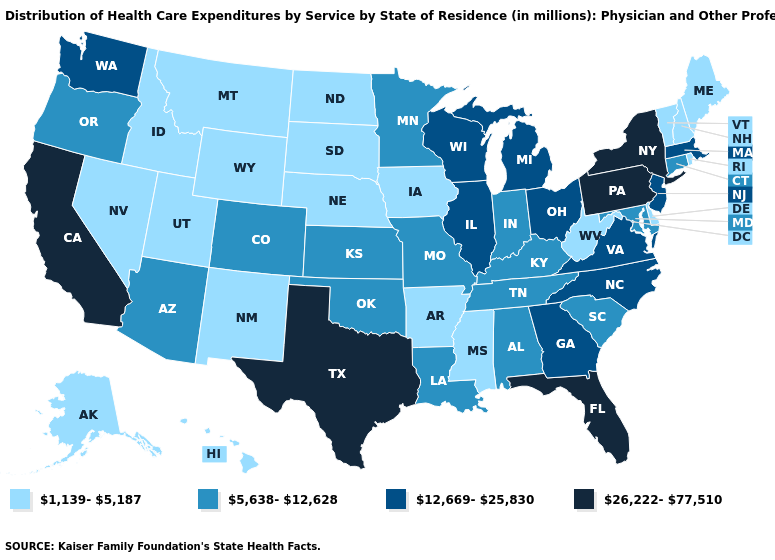Among the states that border Florida , does Georgia have the highest value?
Concise answer only. Yes. What is the value of Nevada?
Quick response, please. 1,139-5,187. Name the states that have a value in the range 5,638-12,628?
Be succinct. Alabama, Arizona, Colorado, Connecticut, Indiana, Kansas, Kentucky, Louisiana, Maryland, Minnesota, Missouri, Oklahoma, Oregon, South Carolina, Tennessee. Among the states that border Alabama , which have the lowest value?
Give a very brief answer. Mississippi. Does the first symbol in the legend represent the smallest category?
Give a very brief answer. Yes. Among the states that border Utah , does Wyoming have the lowest value?
Give a very brief answer. Yes. What is the value of Hawaii?
Concise answer only. 1,139-5,187. Name the states that have a value in the range 26,222-77,510?
Answer briefly. California, Florida, New York, Pennsylvania, Texas. Name the states that have a value in the range 1,139-5,187?
Be succinct. Alaska, Arkansas, Delaware, Hawaii, Idaho, Iowa, Maine, Mississippi, Montana, Nebraska, Nevada, New Hampshire, New Mexico, North Dakota, Rhode Island, South Dakota, Utah, Vermont, West Virginia, Wyoming. Does the first symbol in the legend represent the smallest category?
Concise answer only. Yes. Name the states that have a value in the range 26,222-77,510?
Give a very brief answer. California, Florida, New York, Pennsylvania, Texas. Does South Carolina have the same value as Tennessee?
Concise answer only. Yes. Name the states that have a value in the range 1,139-5,187?
Write a very short answer. Alaska, Arkansas, Delaware, Hawaii, Idaho, Iowa, Maine, Mississippi, Montana, Nebraska, Nevada, New Hampshire, New Mexico, North Dakota, Rhode Island, South Dakota, Utah, Vermont, West Virginia, Wyoming. Is the legend a continuous bar?
Short answer required. No. What is the value of New Mexico?
Give a very brief answer. 1,139-5,187. 